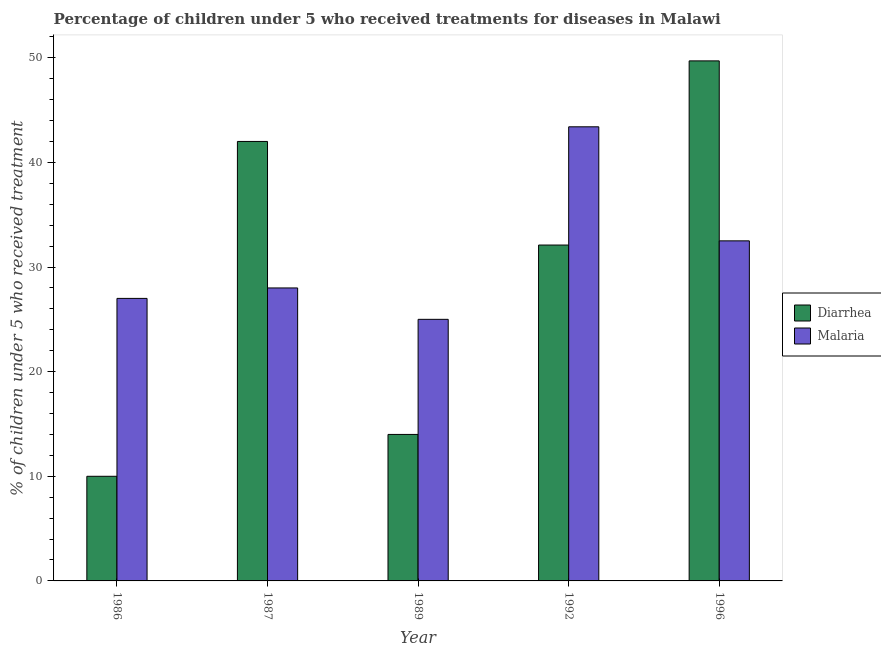How many different coloured bars are there?
Give a very brief answer. 2. How many bars are there on the 2nd tick from the right?
Provide a short and direct response. 2. In how many cases, is the number of bars for a given year not equal to the number of legend labels?
Provide a short and direct response. 0. What is the percentage of children who received treatment for malaria in 1992?
Your answer should be very brief. 43.4. Across all years, what is the maximum percentage of children who received treatment for diarrhoea?
Offer a very short reply. 49.7. Across all years, what is the minimum percentage of children who received treatment for malaria?
Make the answer very short. 25. In which year was the percentage of children who received treatment for diarrhoea minimum?
Keep it short and to the point. 1986. What is the total percentage of children who received treatment for malaria in the graph?
Keep it short and to the point. 155.9. What is the difference between the percentage of children who received treatment for diarrhoea in 1986 and that in 1987?
Your answer should be compact. -32. What is the average percentage of children who received treatment for malaria per year?
Provide a short and direct response. 31.18. In the year 1987, what is the difference between the percentage of children who received treatment for diarrhoea and percentage of children who received treatment for malaria?
Provide a succinct answer. 0. What is the ratio of the percentage of children who received treatment for diarrhoea in 1992 to that in 1996?
Your response must be concise. 0.65. What is the difference between the highest and the second highest percentage of children who received treatment for malaria?
Your answer should be compact. 10.9. What is the difference between the highest and the lowest percentage of children who received treatment for diarrhoea?
Your response must be concise. 39.7. In how many years, is the percentage of children who received treatment for diarrhoea greater than the average percentage of children who received treatment for diarrhoea taken over all years?
Offer a terse response. 3. What does the 1st bar from the left in 1986 represents?
Ensure brevity in your answer.  Diarrhea. What does the 1st bar from the right in 1992 represents?
Keep it short and to the point. Malaria. Are all the bars in the graph horizontal?
Make the answer very short. No. How many years are there in the graph?
Your answer should be very brief. 5. Are the values on the major ticks of Y-axis written in scientific E-notation?
Your answer should be compact. No. Where does the legend appear in the graph?
Ensure brevity in your answer.  Center right. How are the legend labels stacked?
Offer a terse response. Vertical. What is the title of the graph?
Provide a short and direct response. Percentage of children under 5 who received treatments for diseases in Malawi. What is the label or title of the Y-axis?
Give a very brief answer. % of children under 5 who received treatment. What is the % of children under 5 who received treatment in Diarrhea in 1986?
Give a very brief answer. 10. What is the % of children under 5 who received treatment in Malaria in 1986?
Your answer should be very brief. 27. What is the % of children under 5 who received treatment of Diarrhea in 1987?
Make the answer very short. 42. What is the % of children under 5 who received treatment of Diarrhea in 1989?
Your response must be concise. 14. What is the % of children under 5 who received treatment of Malaria in 1989?
Offer a very short reply. 25. What is the % of children under 5 who received treatment in Diarrhea in 1992?
Ensure brevity in your answer.  32.1. What is the % of children under 5 who received treatment of Malaria in 1992?
Give a very brief answer. 43.4. What is the % of children under 5 who received treatment in Diarrhea in 1996?
Ensure brevity in your answer.  49.7. What is the % of children under 5 who received treatment of Malaria in 1996?
Make the answer very short. 32.5. Across all years, what is the maximum % of children under 5 who received treatment in Diarrhea?
Keep it short and to the point. 49.7. Across all years, what is the maximum % of children under 5 who received treatment of Malaria?
Keep it short and to the point. 43.4. Across all years, what is the minimum % of children under 5 who received treatment of Malaria?
Provide a short and direct response. 25. What is the total % of children under 5 who received treatment in Diarrhea in the graph?
Keep it short and to the point. 147.8. What is the total % of children under 5 who received treatment in Malaria in the graph?
Provide a succinct answer. 155.9. What is the difference between the % of children under 5 who received treatment in Diarrhea in 1986 and that in 1987?
Make the answer very short. -32. What is the difference between the % of children under 5 who received treatment of Diarrhea in 1986 and that in 1989?
Your answer should be compact. -4. What is the difference between the % of children under 5 who received treatment of Malaria in 1986 and that in 1989?
Your answer should be compact. 2. What is the difference between the % of children under 5 who received treatment in Diarrhea in 1986 and that in 1992?
Provide a succinct answer. -22.1. What is the difference between the % of children under 5 who received treatment of Malaria in 1986 and that in 1992?
Your response must be concise. -16.4. What is the difference between the % of children under 5 who received treatment in Diarrhea in 1986 and that in 1996?
Provide a succinct answer. -39.7. What is the difference between the % of children under 5 who received treatment of Diarrhea in 1987 and that in 1989?
Your response must be concise. 28. What is the difference between the % of children under 5 who received treatment in Malaria in 1987 and that in 1992?
Provide a short and direct response. -15.4. What is the difference between the % of children under 5 who received treatment of Malaria in 1987 and that in 1996?
Give a very brief answer. -4.5. What is the difference between the % of children under 5 who received treatment in Diarrhea in 1989 and that in 1992?
Offer a very short reply. -18.1. What is the difference between the % of children under 5 who received treatment in Malaria in 1989 and that in 1992?
Make the answer very short. -18.4. What is the difference between the % of children under 5 who received treatment of Diarrhea in 1989 and that in 1996?
Offer a terse response. -35.7. What is the difference between the % of children under 5 who received treatment in Malaria in 1989 and that in 1996?
Give a very brief answer. -7.5. What is the difference between the % of children under 5 who received treatment of Diarrhea in 1992 and that in 1996?
Your answer should be very brief. -17.6. What is the difference between the % of children under 5 who received treatment in Malaria in 1992 and that in 1996?
Your answer should be very brief. 10.9. What is the difference between the % of children under 5 who received treatment in Diarrhea in 1986 and the % of children under 5 who received treatment in Malaria in 1989?
Make the answer very short. -15. What is the difference between the % of children under 5 who received treatment of Diarrhea in 1986 and the % of children under 5 who received treatment of Malaria in 1992?
Offer a terse response. -33.4. What is the difference between the % of children under 5 who received treatment of Diarrhea in 1986 and the % of children under 5 who received treatment of Malaria in 1996?
Offer a terse response. -22.5. What is the difference between the % of children under 5 who received treatment in Diarrhea in 1987 and the % of children under 5 who received treatment in Malaria in 1996?
Your answer should be very brief. 9.5. What is the difference between the % of children under 5 who received treatment in Diarrhea in 1989 and the % of children under 5 who received treatment in Malaria in 1992?
Provide a succinct answer. -29.4. What is the difference between the % of children under 5 who received treatment in Diarrhea in 1989 and the % of children under 5 who received treatment in Malaria in 1996?
Your answer should be compact. -18.5. What is the difference between the % of children under 5 who received treatment in Diarrhea in 1992 and the % of children under 5 who received treatment in Malaria in 1996?
Give a very brief answer. -0.4. What is the average % of children under 5 who received treatment of Diarrhea per year?
Offer a very short reply. 29.56. What is the average % of children under 5 who received treatment of Malaria per year?
Your response must be concise. 31.18. In the year 1987, what is the difference between the % of children under 5 who received treatment in Diarrhea and % of children under 5 who received treatment in Malaria?
Provide a succinct answer. 14. What is the ratio of the % of children under 5 who received treatment of Diarrhea in 1986 to that in 1987?
Your answer should be very brief. 0.24. What is the ratio of the % of children under 5 who received treatment in Malaria in 1986 to that in 1987?
Provide a short and direct response. 0.96. What is the ratio of the % of children under 5 who received treatment of Diarrhea in 1986 to that in 1992?
Offer a very short reply. 0.31. What is the ratio of the % of children under 5 who received treatment of Malaria in 1986 to that in 1992?
Ensure brevity in your answer.  0.62. What is the ratio of the % of children under 5 who received treatment in Diarrhea in 1986 to that in 1996?
Provide a short and direct response. 0.2. What is the ratio of the % of children under 5 who received treatment in Malaria in 1986 to that in 1996?
Provide a succinct answer. 0.83. What is the ratio of the % of children under 5 who received treatment of Malaria in 1987 to that in 1989?
Offer a terse response. 1.12. What is the ratio of the % of children under 5 who received treatment of Diarrhea in 1987 to that in 1992?
Ensure brevity in your answer.  1.31. What is the ratio of the % of children under 5 who received treatment of Malaria in 1987 to that in 1992?
Offer a terse response. 0.65. What is the ratio of the % of children under 5 who received treatment in Diarrhea in 1987 to that in 1996?
Give a very brief answer. 0.85. What is the ratio of the % of children under 5 who received treatment of Malaria in 1987 to that in 1996?
Give a very brief answer. 0.86. What is the ratio of the % of children under 5 who received treatment of Diarrhea in 1989 to that in 1992?
Ensure brevity in your answer.  0.44. What is the ratio of the % of children under 5 who received treatment in Malaria in 1989 to that in 1992?
Your response must be concise. 0.58. What is the ratio of the % of children under 5 who received treatment in Diarrhea in 1989 to that in 1996?
Ensure brevity in your answer.  0.28. What is the ratio of the % of children under 5 who received treatment in Malaria in 1989 to that in 1996?
Make the answer very short. 0.77. What is the ratio of the % of children under 5 who received treatment of Diarrhea in 1992 to that in 1996?
Ensure brevity in your answer.  0.65. What is the ratio of the % of children under 5 who received treatment in Malaria in 1992 to that in 1996?
Your response must be concise. 1.34. What is the difference between the highest and the lowest % of children under 5 who received treatment in Diarrhea?
Provide a short and direct response. 39.7. What is the difference between the highest and the lowest % of children under 5 who received treatment of Malaria?
Provide a short and direct response. 18.4. 